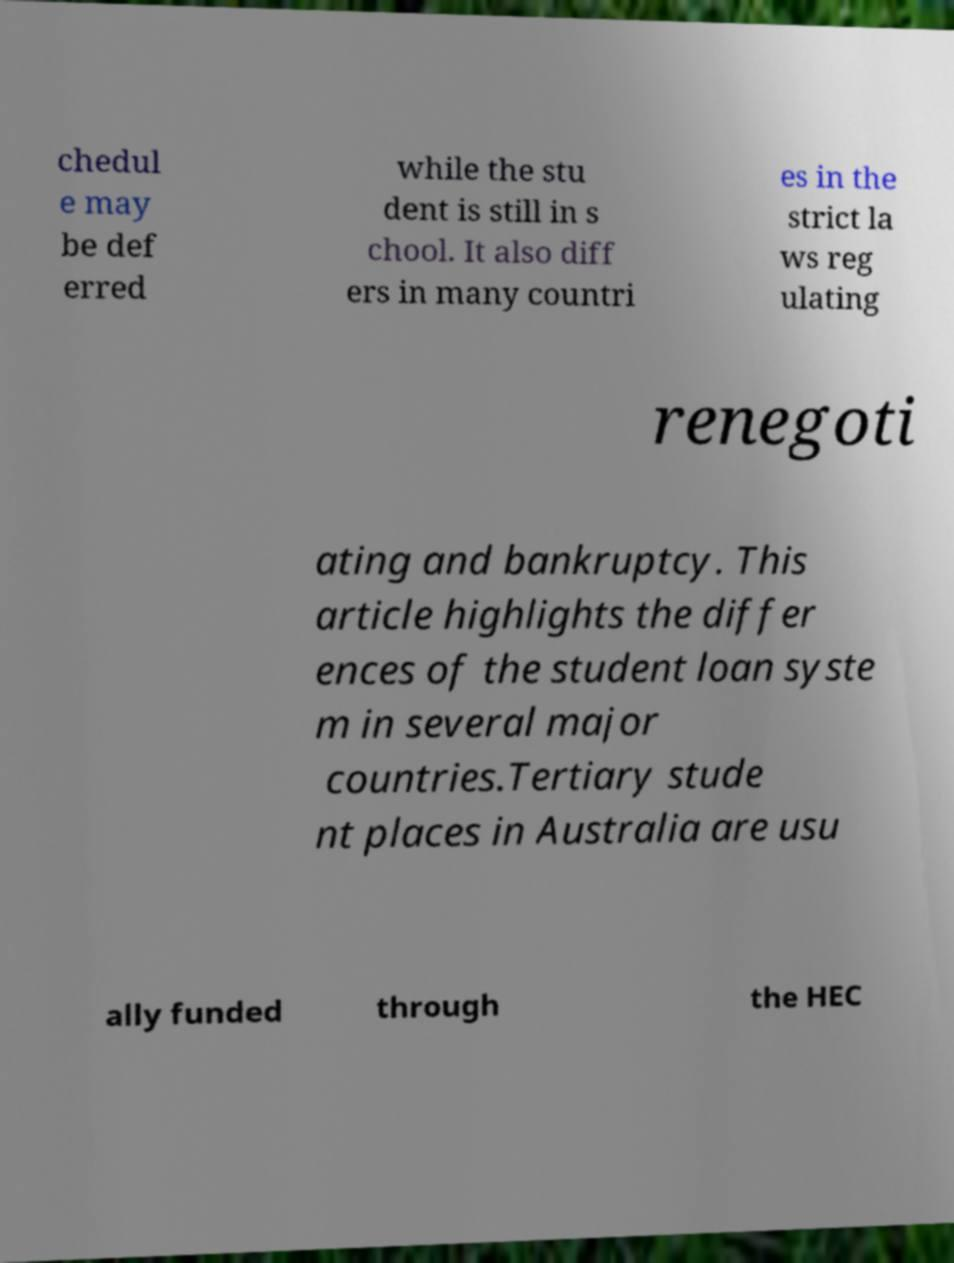Please read and relay the text visible in this image. What does it say? chedul e may be def erred while the stu dent is still in s chool. It also diff ers in many countri es in the strict la ws reg ulating renegoti ating and bankruptcy. This article highlights the differ ences of the student loan syste m in several major countries.Tertiary stude nt places in Australia are usu ally funded through the HEC 